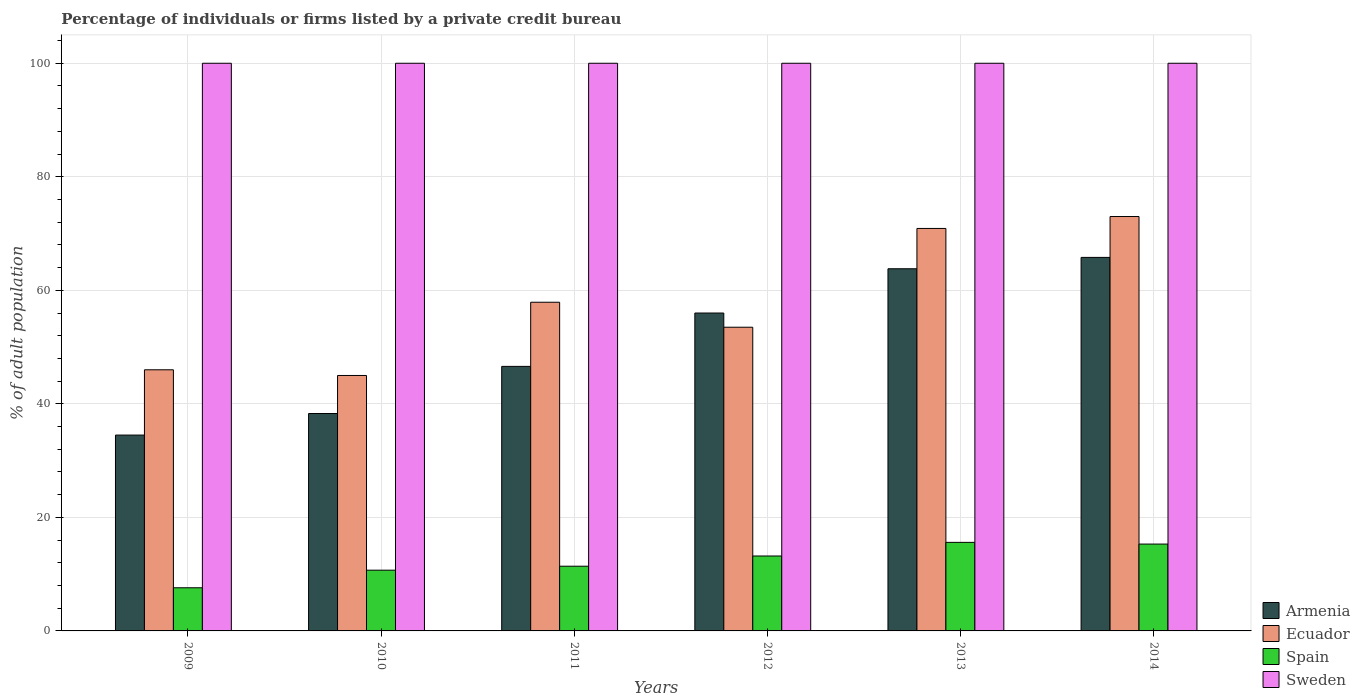How many groups of bars are there?
Keep it short and to the point. 6. Are the number of bars per tick equal to the number of legend labels?
Provide a succinct answer. Yes. Are the number of bars on each tick of the X-axis equal?
Provide a short and direct response. Yes. What is the percentage of population listed by a private credit bureau in Ecuador in 2013?
Give a very brief answer. 70.9. Across all years, what is the maximum percentage of population listed by a private credit bureau in Armenia?
Provide a succinct answer. 65.8. In which year was the percentage of population listed by a private credit bureau in Sweden maximum?
Your response must be concise. 2009. In which year was the percentage of population listed by a private credit bureau in Armenia minimum?
Make the answer very short. 2009. What is the total percentage of population listed by a private credit bureau in Spain in the graph?
Your answer should be very brief. 73.8. What is the difference between the percentage of population listed by a private credit bureau in Ecuador in 2009 and that in 2010?
Offer a very short reply. 1. What is the difference between the percentage of population listed by a private credit bureau in Sweden in 2012 and the percentage of population listed by a private credit bureau in Ecuador in 2013?
Your response must be concise. 29.1. What is the average percentage of population listed by a private credit bureau in Spain per year?
Make the answer very short. 12.3. In the year 2012, what is the difference between the percentage of population listed by a private credit bureau in Ecuador and percentage of population listed by a private credit bureau in Spain?
Keep it short and to the point. 40.3. What is the ratio of the percentage of population listed by a private credit bureau in Ecuador in 2009 to that in 2010?
Keep it short and to the point. 1.02. Is the percentage of population listed by a private credit bureau in Armenia in 2009 less than that in 2013?
Offer a terse response. Yes. Is the difference between the percentage of population listed by a private credit bureau in Ecuador in 2011 and 2014 greater than the difference between the percentage of population listed by a private credit bureau in Spain in 2011 and 2014?
Make the answer very short. No. What is the difference between the highest and the lowest percentage of population listed by a private credit bureau in Spain?
Provide a succinct answer. 8. Is the sum of the percentage of population listed by a private credit bureau in Spain in 2010 and 2012 greater than the maximum percentage of population listed by a private credit bureau in Sweden across all years?
Provide a succinct answer. No. What does the 3rd bar from the left in 2009 represents?
Your response must be concise. Spain. What does the 4th bar from the right in 2011 represents?
Your response must be concise. Armenia. What is the difference between two consecutive major ticks on the Y-axis?
Your answer should be very brief. 20. Does the graph contain grids?
Your response must be concise. Yes. How many legend labels are there?
Provide a short and direct response. 4. What is the title of the graph?
Your response must be concise. Percentage of individuals or firms listed by a private credit bureau. What is the label or title of the X-axis?
Your response must be concise. Years. What is the label or title of the Y-axis?
Offer a terse response. % of adult population. What is the % of adult population of Armenia in 2009?
Offer a very short reply. 34.5. What is the % of adult population of Ecuador in 2009?
Keep it short and to the point. 46. What is the % of adult population of Spain in 2009?
Offer a terse response. 7.6. What is the % of adult population of Armenia in 2010?
Offer a very short reply. 38.3. What is the % of adult population in Armenia in 2011?
Offer a terse response. 46.6. What is the % of adult population of Ecuador in 2011?
Your answer should be compact. 57.9. What is the % of adult population of Spain in 2011?
Give a very brief answer. 11.4. What is the % of adult population in Sweden in 2011?
Provide a succinct answer. 100. What is the % of adult population in Ecuador in 2012?
Provide a short and direct response. 53.5. What is the % of adult population in Spain in 2012?
Your answer should be compact. 13.2. What is the % of adult population in Armenia in 2013?
Offer a terse response. 63.8. What is the % of adult population in Ecuador in 2013?
Your response must be concise. 70.9. What is the % of adult population of Sweden in 2013?
Give a very brief answer. 100. What is the % of adult population in Armenia in 2014?
Offer a very short reply. 65.8. What is the % of adult population in Ecuador in 2014?
Ensure brevity in your answer.  73. What is the % of adult population of Spain in 2014?
Your answer should be very brief. 15.3. What is the % of adult population in Sweden in 2014?
Your response must be concise. 100. Across all years, what is the maximum % of adult population of Armenia?
Your response must be concise. 65.8. Across all years, what is the maximum % of adult population of Ecuador?
Provide a short and direct response. 73. Across all years, what is the minimum % of adult population of Armenia?
Ensure brevity in your answer.  34.5. Across all years, what is the minimum % of adult population in Spain?
Provide a succinct answer. 7.6. Across all years, what is the minimum % of adult population of Sweden?
Ensure brevity in your answer.  100. What is the total % of adult population of Armenia in the graph?
Make the answer very short. 305. What is the total % of adult population in Ecuador in the graph?
Your answer should be very brief. 346.3. What is the total % of adult population in Spain in the graph?
Make the answer very short. 73.8. What is the total % of adult population of Sweden in the graph?
Your answer should be compact. 600. What is the difference between the % of adult population of Ecuador in 2009 and that in 2010?
Provide a short and direct response. 1. What is the difference between the % of adult population in Spain in 2009 and that in 2010?
Your response must be concise. -3.1. What is the difference between the % of adult population of Armenia in 2009 and that in 2011?
Provide a short and direct response. -12.1. What is the difference between the % of adult population of Sweden in 2009 and that in 2011?
Give a very brief answer. 0. What is the difference between the % of adult population in Armenia in 2009 and that in 2012?
Offer a terse response. -21.5. What is the difference between the % of adult population in Armenia in 2009 and that in 2013?
Offer a very short reply. -29.3. What is the difference between the % of adult population of Ecuador in 2009 and that in 2013?
Offer a terse response. -24.9. What is the difference between the % of adult population in Spain in 2009 and that in 2013?
Your answer should be compact. -8. What is the difference between the % of adult population of Sweden in 2009 and that in 2013?
Give a very brief answer. 0. What is the difference between the % of adult population in Armenia in 2009 and that in 2014?
Give a very brief answer. -31.3. What is the difference between the % of adult population in Ecuador in 2009 and that in 2014?
Your response must be concise. -27. What is the difference between the % of adult population of Spain in 2009 and that in 2014?
Provide a short and direct response. -7.7. What is the difference between the % of adult population in Ecuador in 2010 and that in 2011?
Offer a terse response. -12.9. What is the difference between the % of adult population of Spain in 2010 and that in 2011?
Your answer should be compact. -0.7. What is the difference between the % of adult population of Sweden in 2010 and that in 2011?
Offer a terse response. 0. What is the difference between the % of adult population of Armenia in 2010 and that in 2012?
Your response must be concise. -17.7. What is the difference between the % of adult population of Ecuador in 2010 and that in 2012?
Make the answer very short. -8.5. What is the difference between the % of adult population of Sweden in 2010 and that in 2012?
Your answer should be very brief. 0. What is the difference between the % of adult population in Armenia in 2010 and that in 2013?
Provide a succinct answer. -25.5. What is the difference between the % of adult population in Ecuador in 2010 and that in 2013?
Your answer should be compact. -25.9. What is the difference between the % of adult population of Spain in 2010 and that in 2013?
Ensure brevity in your answer.  -4.9. What is the difference between the % of adult population in Armenia in 2010 and that in 2014?
Ensure brevity in your answer.  -27.5. What is the difference between the % of adult population of Ecuador in 2010 and that in 2014?
Provide a succinct answer. -28. What is the difference between the % of adult population in Sweden in 2010 and that in 2014?
Make the answer very short. 0. What is the difference between the % of adult population in Armenia in 2011 and that in 2012?
Keep it short and to the point. -9.4. What is the difference between the % of adult population in Spain in 2011 and that in 2012?
Your answer should be very brief. -1.8. What is the difference between the % of adult population of Sweden in 2011 and that in 2012?
Your response must be concise. 0. What is the difference between the % of adult population of Armenia in 2011 and that in 2013?
Provide a short and direct response. -17.2. What is the difference between the % of adult population of Spain in 2011 and that in 2013?
Give a very brief answer. -4.2. What is the difference between the % of adult population in Sweden in 2011 and that in 2013?
Ensure brevity in your answer.  0. What is the difference between the % of adult population in Armenia in 2011 and that in 2014?
Your answer should be very brief. -19.2. What is the difference between the % of adult population in Ecuador in 2011 and that in 2014?
Offer a terse response. -15.1. What is the difference between the % of adult population in Spain in 2011 and that in 2014?
Your answer should be compact. -3.9. What is the difference between the % of adult population in Ecuador in 2012 and that in 2013?
Make the answer very short. -17.4. What is the difference between the % of adult population of Sweden in 2012 and that in 2013?
Offer a terse response. 0. What is the difference between the % of adult population in Ecuador in 2012 and that in 2014?
Keep it short and to the point. -19.5. What is the difference between the % of adult population of Sweden in 2012 and that in 2014?
Keep it short and to the point. 0. What is the difference between the % of adult population of Armenia in 2013 and that in 2014?
Make the answer very short. -2. What is the difference between the % of adult population in Ecuador in 2013 and that in 2014?
Your answer should be very brief. -2.1. What is the difference between the % of adult population of Armenia in 2009 and the % of adult population of Ecuador in 2010?
Give a very brief answer. -10.5. What is the difference between the % of adult population in Armenia in 2009 and the % of adult population in Spain in 2010?
Give a very brief answer. 23.8. What is the difference between the % of adult population in Armenia in 2009 and the % of adult population in Sweden in 2010?
Your response must be concise. -65.5. What is the difference between the % of adult population in Ecuador in 2009 and the % of adult population in Spain in 2010?
Give a very brief answer. 35.3. What is the difference between the % of adult population in Ecuador in 2009 and the % of adult population in Sweden in 2010?
Ensure brevity in your answer.  -54. What is the difference between the % of adult population in Spain in 2009 and the % of adult population in Sweden in 2010?
Keep it short and to the point. -92.4. What is the difference between the % of adult population of Armenia in 2009 and the % of adult population of Ecuador in 2011?
Provide a succinct answer. -23.4. What is the difference between the % of adult population in Armenia in 2009 and the % of adult population in Spain in 2011?
Your answer should be compact. 23.1. What is the difference between the % of adult population in Armenia in 2009 and the % of adult population in Sweden in 2011?
Make the answer very short. -65.5. What is the difference between the % of adult population of Ecuador in 2009 and the % of adult population of Spain in 2011?
Make the answer very short. 34.6. What is the difference between the % of adult population in Ecuador in 2009 and the % of adult population in Sweden in 2011?
Make the answer very short. -54. What is the difference between the % of adult population of Spain in 2009 and the % of adult population of Sweden in 2011?
Ensure brevity in your answer.  -92.4. What is the difference between the % of adult population in Armenia in 2009 and the % of adult population in Spain in 2012?
Make the answer very short. 21.3. What is the difference between the % of adult population in Armenia in 2009 and the % of adult population in Sweden in 2012?
Provide a short and direct response. -65.5. What is the difference between the % of adult population in Ecuador in 2009 and the % of adult population in Spain in 2012?
Offer a very short reply. 32.8. What is the difference between the % of adult population in Ecuador in 2009 and the % of adult population in Sweden in 2012?
Ensure brevity in your answer.  -54. What is the difference between the % of adult population in Spain in 2009 and the % of adult population in Sweden in 2012?
Your answer should be compact. -92.4. What is the difference between the % of adult population of Armenia in 2009 and the % of adult population of Ecuador in 2013?
Make the answer very short. -36.4. What is the difference between the % of adult population of Armenia in 2009 and the % of adult population of Spain in 2013?
Your response must be concise. 18.9. What is the difference between the % of adult population in Armenia in 2009 and the % of adult population in Sweden in 2013?
Offer a very short reply. -65.5. What is the difference between the % of adult population of Ecuador in 2009 and the % of adult population of Spain in 2013?
Your answer should be very brief. 30.4. What is the difference between the % of adult population of Ecuador in 2009 and the % of adult population of Sweden in 2013?
Your response must be concise. -54. What is the difference between the % of adult population in Spain in 2009 and the % of adult population in Sweden in 2013?
Your answer should be compact. -92.4. What is the difference between the % of adult population of Armenia in 2009 and the % of adult population of Ecuador in 2014?
Your response must be concise. -38.5. What is the difference between the % of adult population in Armenia in 2009 and the % of adult population in Sweden in 2014?
Give a very brief answer. -65.5. What is the difference between the % of adult population of Ecuador in 2009 and the % of adult population of Spain in 2014?
Make the answer very short. 30.7. What is the difference between the % of adult population of Ecuador in 2009 and the % of adult population of Sweden in 2014?
Ensure brevity in your answer.  -54. What is the difference between the % of adult population of Spain in 2009 and the % of adult population of Sweden in 2014?
Provide a succinct answer. -92.4. What is the difference between the % of adult population of Armenia in 2010 and the % of adult population of Ecuador in 2011?
Your answer should be very brief. -19.6. What is the difference between the % of adult population in Armenia in 2010 and the % of adult population in Spain in 2011?
Your answer should be very brief. 26.9. What is the difference between the % of adult population in Armenia in 2010 and the % of adult population in Sweden in 2011?
Offer a very short reply. -61.7. What is the difference between the % of adult population of Ecuador in 2010 and the % of adult population of Spain in 2011?
Give a very brief answer. 33.6. What is the difference between the % of adult population of Ecuador in 2010 and the % of adult population of Sweden in 2011?
Make the answer very short. -55. What is the difference between the % of adult population of Spain in 2010 and the % of adult population of Sweden in 2011?
Make the answer very short. -89.3. What is the difference between the % of adult population of Armenia in 2010 and the % of adult population of Ecuador in 2012?
Provide a succinct answer. -15.2. What is the difference between the % of adult population of Armenia in 2010 and the % of adult population of Spain in 2012?
Ensure brevity in your answer.  25.1. What is the difference between the % of adult population in Armenia in 2010 and the % of adult population in Sweden in 2012?
Make the answer very short. -61.7. What is the difference between the % of adult population in Ecuador in 2010 and the % of adult population in Spain in 2012?
Offer a terse response. 31.8. What is the difference between the % of adult population in Ecuador in 2010 and the % of adult population in Sweden in 2012?
Keep it short and to the point. -55. What is the difference between the % of adult population in Spain in 2010 and the % of adult population in Sweden in 2012?
Your answer should be very brief. -89.3. What is the difference between the % of adult population in Armenia in 2010 and the % of adult population in Ecuador in 2013?
Provide a short and direct response. -32.6. What is the difference between the % of adult population in Armenia in 2010 and the % of adult population in Spain in 2013?
Make the answer very short. 22.7. What is the difference between the % of adult population of Armenia in 2010 and the % of adult population of Sweden in 2013?
Make the answer very short. -61.7. What is the difference between the % of adult population of Ecuador in 2010 and the % of adult population of Spain in 2013?
Make the answer very short. 29.4. What is the difference between the % of adult population in Ecuador in 2010 and the % of adult population in Sweden in 2013?
Provide a short and direct response. -55. What is the difference between the % of adult population in Spain in 2010 and the % of adult population in Sweden in 2013?
Your response must be concise. -89.3. What is the difference between the % of adult population in Armenia in 2010 and the % of adult population in Ecuador in 2014?
Your answer should be very brief. -34.7. What is the difference between the % of adult population in Armenia in 2010 and the % of adult population in Sweden in 2014?
Provide a succinct answer. -61.7. What is the difference between the % of adult population of Ecuador in 2010 and the % of adult population of Spain in 2014?
Your answer should be very brief. 29.7. What is the difference between the % of adult population of Ecuador in 2010 and the % of adult population of Sweden in 2014?
Your response must be concise. -55. What is the difference between the % of adult population in Spain in 2010 and the % of adult population in Sweden in 2014?
Keep it short and to the point. -89.3. What is the difference between the % of adult population of Armenia in 2011 and the % of adult population of Ecuador in 2012?
Provide a succinct answer. -6.9. What is the difference between the % of adult population of Armenia in 2011 and the % of adult population of Spain in 2012?
Provide a short and direct response. 33.4. What is the difference between the % of adult population of Armenia in 2011 and the % of adult population of Sweden in 2012?
Provide a short and direct response. -53.4. What is the difference between the % of adult population of Ecuador in 2011 and the % of adult population of Spain in 2012?
Keep it short and to the point. 44.7. What is the difference between the % of adult population of Ecuador in 2011 and the % of adult population of Sweden in 2012?
Offer a terse response. -42.1. What is the difference between the % of adult population in Spain in 2011 and the % of adult population in Sweden in 2012?
Your response must be concise. -88.6. What is the difference between the % of adult population of Armenia in 2011 and the % of adult population of Ecuador in 2013?
Your answer should be very brief. -24.3. What is the difference between the % of adult population in Armenia in 2011 and the % of adult population in Sweden in 2013?
Offer a terse response. -53.4. What is the difference between the % of adult population of Ecuador in 2011 and the % of adult population of Spain in 2013?
Ensure brevity in your answer.  42.3. What is the difference between the % of adult population in Ecuador in 2011 and the % of adult population in Sweden in 2013?
Offer a very short reply. -42.1. What is the difference between the % of adult population in Spain in 2011 and the % of adult population in Sweden in 2013?
Your answer should be compact. -88.6. What is the difference between the % of adult population in Armenia in 2011 and the % of adult population in Ecuador in 2014?
Offer a very short reply. -26.4. What is the difference between the % of adult population in Armenia in 2011 and the % of adult population in Spain in 2014?
Your answer should be compact. 31.3. What is the difference between the % of adult population in Armenia in 2011 and the % of adult population in Sweden in 2014?
Make the answer very short. -53.4. What is the difference between the % of adult population of Ecuador in 2011 and the % of adult population of Spain in 2014?
Your response must be concise. 42.6. What is the difference between the % of adult population of Ecuador in 2011 and the % of adult population of Sweden in 2014?
Give a very brief answer. -42.1. What is the difference between the % of adult population of Spain in 2011 and the % of adult population of Sweden in 2014?
Offer a terse response. -88.6. What is the difference between the % of adult population of Armenia in 2012 and the % of adult population of Ecuador in 2013?
Provide a succinct answer. -14.9. What is the difference between the % of adult population of Armenia in 2012 and the % of adult population of Spain in 2013?
Give a very brief answer. 40.4. What is the difference between the % of adult population in Armenia in 2012 and the % of adult population in Sweden in 2013?
Keep it short and to the point. -44. What is the difference between the % of adult population in Ecuador in 2012 and the % of adult population in Spain in 2013?
Your response must be concise. 37.9. What is the difference between the % of adult population in Ecuador in 2012 and the % of adult population in Sweden in 2013?
Provide a short and direct response. -46.5. What is the difference between the % of adult population in Spain in 2012 and the % of adult population in Sweden in 2013?
Your response must be concise. -86.8. What is the difference between the % of adult population of Armenia in 2012 and the % of adult population of Spain in 2014?
Ensure brevity in your answer.  40.7. What is the difference between the % of adult population in Armenia in 2012 and the % of adult population in Sweden in 2014?
Your answer should be compact. -44. What is the difference between the % of adult population in Ecuador in 2012 and the % of adult population in Spain in 2014?
Offer a very short reply. 38.2. What is the difference between the % of adult population in Ecuador in 2012 and the % of adult population in Sweden in 2014?
Give a very brief answer. -46.5. What is the difference between the % of adult population of Spain in 2012 and the % of adult population of Sweden in 2014?
Ensure brevity in your answer.  -86.8. What is the difference between the % of adult population in Armenia in 2013 and the % of adult population in Spain in 2014?
Keep it short and to the point. 48.5. What is the difference between the % of adult population in Armenia in 2013 and the % of adult population in Sweden in 2014?
Make the answer very short. -36.2. What is the difference between the % of adult population of Ecuador in 2013 and the % of adult population of Spain in 2014?
Ensure brevity in your answer.  55.6. What is the difference between the % of adult population of Ecuador in 2013 and the % of adult population of Sweden in 2014?
Provide a short and direct response. -29.1. What is the difference between the % of adult population in Spain in 2013 and the % of adult population in Sweden in 2014?
Offer a very short reply. -84.4. What is the average % of adult population in Armenia per year?
Your answer should be very brief. 50.83. What is the average % of adult population in Ecuador per year?
Offer a terse response. 57.72. What is the average % of adult population in Spain per year?
Your response must be concise. 12.3. What is the average % of adult population in Sweden per year?
Your answer should be compact. 100. In the year 2009, what is the difference between the % of adult population in Armenia and % of adult population in Ecuador?
Provide a short and direct response. -11.5. In the year 2009, what is the difference between the % of adult population of Armenia and % of adult population of Spain?
Make the answer very short. 26.9. In the year 2009, what is the difference between the % of adult population of Armenia and % of adult population of Sweden?
Ensure brevity in your answer.  -65.5. In the year 2009, what is the difference between the % of adult population in Ecuador and % of adult population in Spain?
Offer a very short reply. 38.4. In the year 2009, what is the difference between the % of adult population of Ecuador and % of adult population of Sweden?
Ensure brevity in your answer.  -54. In the year 2009, what is the difference between the % of adult population in Spain and % of adult population in Sweden?
Ensure brevity in your answer.  -92.4. In the year 2010, what is the difference between the % of adult population in Armenia and % of adult population in Ecuador?
Your answer should be compact. -6.7. In the year 2010, what is the difference between the % of adult population of Armenia and % of adult population of Spain?
Make the answer very short. 27.6. In the year 2010, what is the difference between the % of adult population of Armenia and % of adult population of Sweden?
Your response must be concise. -61.7. In the year 2010, what is the difference between the % of adult population in Ecuador and % of adult population in Spain?
Offer a very short reply. 34.3. In the year 2010, what is the difference between the % of adult population in Ecuador and % of adult population in Sweden?
Your response must be concise. -55. In the year 2010, what is the difference between the % of adult population of Spain and % of adult population of Sweden?
Your answer should be compact. -89.3. In the year 2011, what is the difference between the % of adult population in Armenia and % of adult population in Spain?
Make the answer very short. 35.2. In the year 2011, what is the difference between the % of adult population of Armenia and % of adult population of Sweden?
Make the answer very short. -53.4. In the year 2011, what is the difference between the % of adult population in Ecuador and % of adult population in Spain?
Give a very brief answer. 46.5. In the year 2011, what is the difference between the % of adult population of Ecuador and % of adult population of Sweden?
Offer a very short reply. -42.1. In the year 2011, what is the difference between the % of adult population in Spain and % of adult population in Sweden?
Provide a short and direct response. -88.6. In the year 2012, what is the difference between the % of adult population of Armenia and % of adult population of Spain?
Provide a short and direct response. 42.8. In the year 2012, what is the difference between the % of adult population of Armenia and % of adult population of Sweden?
Keep it short and to the point. -44. In the year 2012, what is the difference between the % of adult population in Ecuador and % of adult population in Spain?
Your answer should be compact. 40.3. In the year 2012, what is the difference between the % of adult population of Ecuador and % of adult population of Sweden?
Offer a very short reply. -46.5. In the year 2012, what is the difference between the % of adult population in Spain and % of adult population in Sweden?
Keep it short and to the point. -86.8. In the year 2013, what is the difference between the % of adult population of Armenia and % of adult population of Spain?
Make the answer very short. 48.2. In the year 2013, what is the difference between the % of adult population of Armenia and % of adult population of Sweden?
Ensure brevity in your answer.  -36.2. In the year 2013, what is the difference between the % of adult population of Ecuador and % of adult population of Spain?
Your answer should be very brief. 55.3. In the year 2013, what is the difference between the % of adult population in Ecuador and % of adult population in Sweden?
Offer a very short reply. -29.1. In the year 2013, what is the difference between the % of adult population of Spain and % of adult population of Sweden?
Provide a short and direct response. -84.4. In the year 2014, what is the difference between the % of adult population in Armenia and % of adult population in Ecuador?
Ensure brevity in your answer.  -7.2. In the year 2014, what is the difference between the % of adult population in Armenia and % of adult population in Spain?
Provide a short and direct response. 50.5. In the year 2014, what is the difference between the % of adult population in Armenia and % of adult population in Sweden?
Keep it short and to the point. -34.2. In the year 2014, what is the difference between the % of adult population in Ecuador and % of adult population in Spain?
Provide a short and direct response. 57.7. In the year 2014, what is the difference between the % of adult population in Spain and % of adult population in Sweden?
Your answer should be compact. -84.7. What is the ratio of the % of adult population of Armenia in 2009 to that in 2010?
Give a very brief answer. 0.9. What is the ratio of the % of adult population of Ecuador in 2009 to that in 2010?
Your answer should be very brief. 1.02. What is the ratio of the % of adult population in Spain in 2009 to that in 2010?
Your response must be concise. 0.71. What is the ratio of the % of adult population of Sweden in 2009 to that in 2010?
Your response must be concise. 1. What is the ratio of the % of adult population of Armenia in 2009 to that in 2011?
Your answer should be very brief. 0.74. What is the ratio of the % of adult population of Ecuador in 2009 to that in 2011?
Provide a short and direct response. 0.79. What is the ratio of the % of adult population in Spain in 2009 to that in 2011?
Offer a terse response. 0.67. What is the ratio of the % of adult population of Armenia in 2009 to that in 2012?
Your answer should be very brief. 0.62. What is the ratio of the % of adult population of Ecuador in 2009 to that in 2012?
Give a very brief answer. 0.86. What is the ratio of the % of adult population of Spain in 2009 to that in 2012?
Provide a succinct answer. 0.58. What is the ratio of the % of adult population of Sweden in 2009 to that in 2012?
Provide a succinct answer. 1. What is the ratio of the % of adult population in Armenia in 2009 to that in 2013?
Your response must be concise. 0.54. What is the ratio of the % of adult population of Ecuador in 2009 to that in 2013?
Provide a short and direct response. 0.65. What is the ratio of the % of adult population of Spain in 2009 to that in 2013?
Your answer should be compact. 0.49. What is the ratio of the % of adult population in Sweden in 2009 to that in 2013?
Give a very brief answer. 1. What is the ratio of the % of adult population in Armenia in 2009 to that in 2014?
Provide a succinct answer. 0.52. What is the ratio of the % of adult population of Ecuador in 2009 to that in 2014?
Your answer should be compact. 0.63. What is the ratio of the % of adult population in Spain in 2009 to that in 2014?
Ensure brevity in your answer.  0.5. What is the ratio of the % of adult population in Armenia in 2010 to that in 2011?
Keep it short and to the point. 0.82. What is the ratio of the % of adult population in Ecuador in 2010 to that in 2011?
Keep it short and to the point. 0.78. What is the ratio of the % of adult population in Spain in 2010 to that in 2011?
Ensure brevity in your answer.  0.94. What is the ratio of the % of adult population in Sweden in 2010 to that in 2011?
Your answer should be compact. 1. What is the ratio of the % of adult population in Armenia in 2010 to that in 2012?
Offer a terse response. 0.68. What is the ratio of the % of adult population of Ecuador in 2010 to that in 2012?
Keep it short and to the point. 0.84. What is the ratio of the % of adult population in Spain in 2010 to that in 2012?
Provide a succinct answer. 0.81. What is the ratio of the % of adult population of Armenia in 2010 to that in 2013?
Your answer should be compact. 0.6. What is the ratio of the % of adult population in Ecuador in 2010 to that in 2013?
Your answer should be very brief. 0.63. What is the ratio of the % of adult population of Spain in 2010 to that in 2013?
Your response must be concise. 0.69. What is the ratio of the % of adult population in Sweden in 2010 to that in 2013?
Offer a terse response. 1. What is the ratio of the % of adult population in Armenia in 2010 to that in 2014?
Provide a short and direct response. 0.58. What is the ratio of the % of adult population in Ecuador in 2010 to that in 2014?
Offer a terse response. 0.62. What is the ratio of the % of adult population in Spain in 2010 to that in 2014?
Keep it short and to the point. 0.7. What is the ratio of the % of adult population in Sweden in 2010 to that in 2014?
Make the answer very short. 1. What is the ratio of the % of adult population of Armenia in 2011 to that in 2012?
Ensure brevity in your answer.  0.83. What is the ratio of the % of adult population in Ecuador in 2011 to that in 2012?
Ensure brevity in your answer.  1.08. What is the ratio of the % of adult population of Spain in 2011 to that in 2012?
Offer a terse response. 0.86. What is the ratio of the % of adult population in Sweden in 2011 to that in 2012?
Your answer should be very brief. 1. What is the ratio of the % of adult population of Armenia in 2011 to that in 2013?
Give a very brief answer. 0.73. What is the ratio of the % of adult population of Ecuador in 2011 to that in 2013?
Keep it short and to the point. 0.82. What is the ratio of the % of adult population in Spain in 2011 to that in 2013?
Keep it short and to the point. 0.73. What is the ratio of the % of adult population in Armenia in 2011 to that in 2014?
Ensure brevity in your answer.  0.71. What is the ratio of the % of adult population of Ecuador in 2011 to that in 2014?
Offer a terse response. 0.79. What is the ratio of the % of adult population of Spain in 2011 to that in 2014?
Make the answer very short. 0.75. What is the ratio of the % of adult population in Sweden in 2011 to that in 2014?
Make the answer very short. 1. What is the ratio of the % of adult population in Armenia in 2012 to that in 2013?
Ensure brevity in your answer.  0.88. What is the ratio of the % of adult population in Ecuador in 2012 to that in 2013?
Keep it short and to the point. 0.75. What is the ratio of the % of adult population of Spain in 2012 to that in 2013?
Ensure brevity in your answer.  0.85. What is the ratio of the % of adult population in Sweden in 2012 to that in 2013?
Ensure brevity in your answer.  1. What is the ratio of the % of adult population in Armenia in 2012 to that in 2014?
Ensure brevity in your answer.  0.85. What is the ratio of the % of adult population of Ecuador in 2012 to that in 2014?
Keep it short and to the point. 0.73. What is the ratio of the % of adult population of Spain in 2012 to that in 2014?
Provide a succinct answer. 0.86. What is the ratio of the % of adult population in Sweden in 2012 to that in 2014?
Give a very brief answer. 1. What is the ratio of the % of adult population of Armenia in 2013 to that in 2014?
Provide a short and direct response. 0.97. What is the ratio of the % of adult population in Ecuador in 2013 to that in 2014?
Your answer should be very brief. 0.97. What is the ratio of the % of adult population in Spain in 2013 to that in 2014?
Ensure brevity in your answer.  1.02. What is the ratio of the % of adult population in Sweden in 2013 to that in 2014?
Your answer should be very brief. 1. What is the difference between the highest and the lowest % of adult population in Armenia?
Make the answer very short. 31.3. 